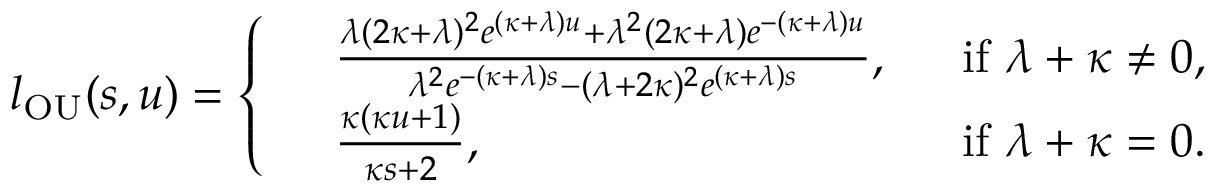Convert formula to latex. <formula><loc_0><loc_0><loc_500><loc_500>l _ { O U } ( s , u ) = \left \{ \begin{array} { r l r } & { \frac { \lambda ( 2 \kappa + \lambda ) ^ { 2 } e ^ { ( \kappa + \lambda ) u } + \lambda ^ { 2 } ( 2 \kappa + \lambda ) e ^ { - ( \kappa + \lambda ) u } } { \lambda ^ { 2 } e ^ { - ( \kappa + \lambda ) s } - ( \lambda + 2 \kappa ) ^ { 2 } e ^ { ( \kappa + \lambda ) s } } , } & { i f \lambda + \kappa \neq 0 , } \\ & { \frac { \kappa ( \kappa u + 1 ) } { \kappa s + 2 } , } & { i f \lambda + \kappa = 0 . } \end{array}</formula> 